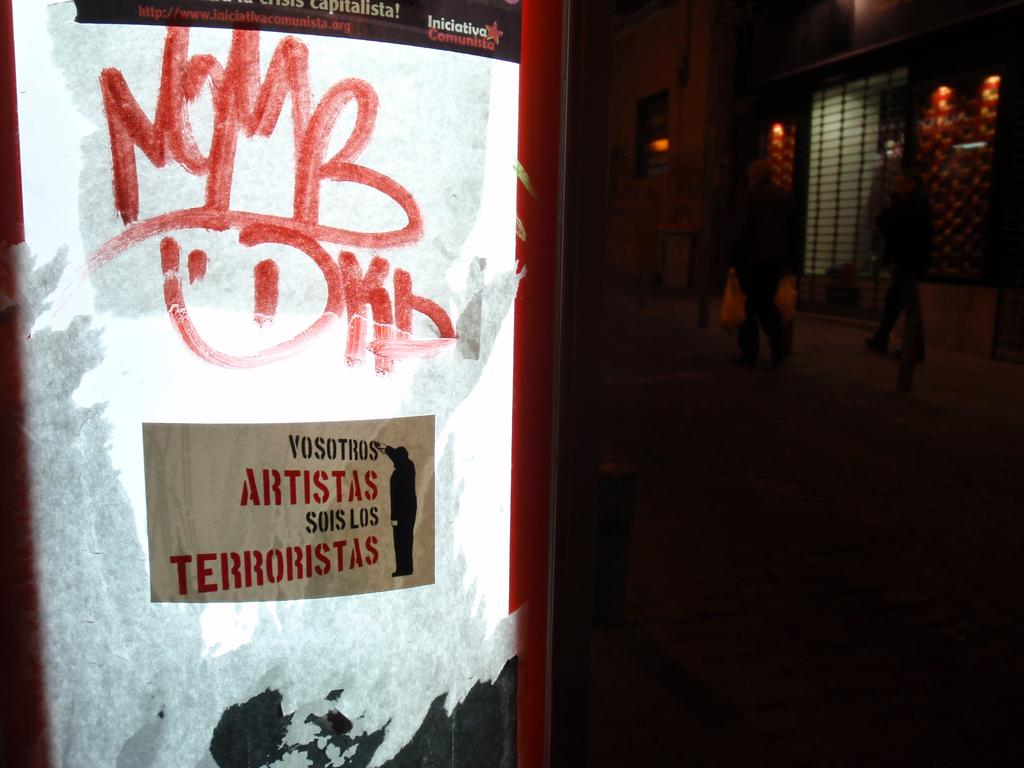<image>
Write a terse but informative summary of the picture. A lighted Iniciativa Communita advertising on a street that has a sticker comparing artists and terrorist. 